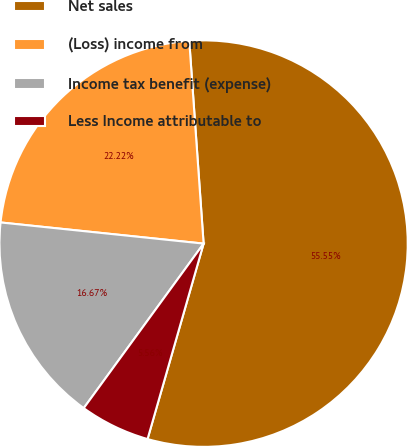Convert chart to OTSL. <chart><loc_0><loc_0><loc_500><loc_500><pie_chart><fcel>Net sales<fcel>(Loss) income from<fcel>Income tax benefit (expense)<fcel>Less Income attributable to<nl><fcel>55.54%<fcel>22.22%<fcel>16.67%<fcel>5.56%<nl></chart> 